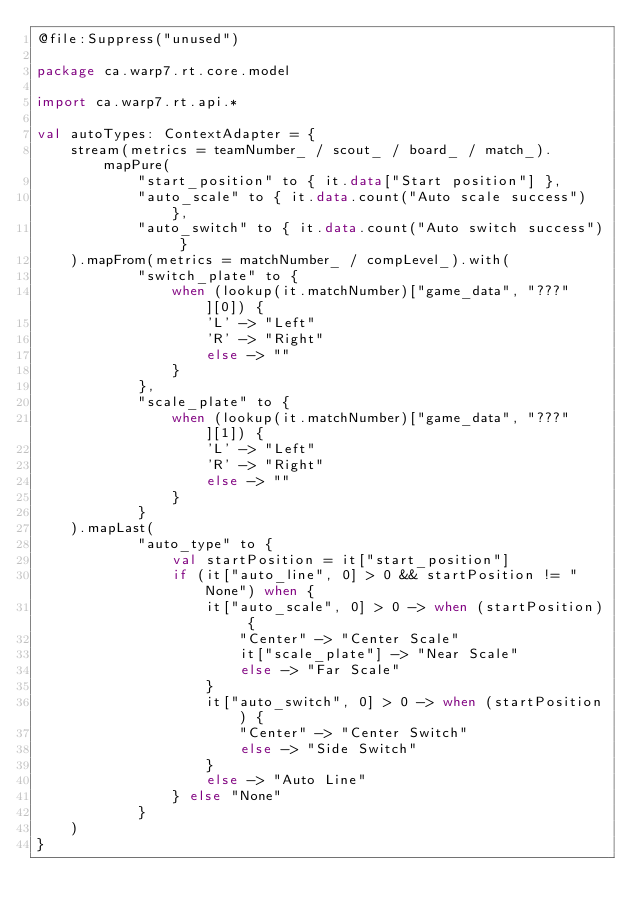<code> <loc_0><loc_0><loc_500><loc_500><_Kotlin_>@file:Suppress("unused")

package ca.warp7.rt.core.model

import ca.warp7.rt.api.*

val autoTypes: ContextAdapter = {
    stream(metrics = teamNumber_ / scout_ / board_ / match_).mapPure(
            "start_position" to { it.data["Start position"] },
            "auto_scale" to { it.data.count("Auto scale success") },
            "auto_switch" to { it.data.count("Auto switch success") }
    ).mapFrom(metrics = matchNumber_ / compLevel_).with(
            "switch_plate" to {
                when (lookup(it.matchNumber)["game_data", "???"][0]) {
                    'L' -> "Left"
                    'R' -> "Right"
                    else -> ""
                }
            },
            "scale_plate" to {
                when (lookup(it.matchNumber)["game_data", "???"][1]) {
                    'L' -> "Left"
                    'R' -> "Right"
                    else -> ""
                }
            }
    ).mapLast(
            "auto_type" to {
                val startPosition = it["start_position"]
                if (it["auto_line", 0] > 0 && startPosition != "None") when {
                    it["auto_scale", 0] > 0 -> when (startPosition) {
                        "Center" -> "Center Scale"
                        it["scale_plate"] -> "Near Scale"
                        else -> "Far Scale"
                    }
                    it["auto_switch", 0] > 0 -> when (startPosition) {
                        "Center" -> "Center Switch"
                        else -> "Side Switch"
                    }
                    else -> "Auto Line"
                } else "None"
            }
    )
}</code> 